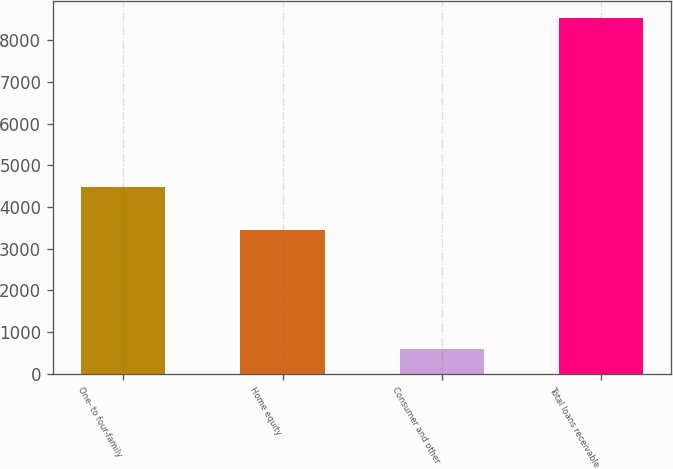Convert chart. <chart><loc_0><loc_0><loc_500><loc_500><bar_chart><fcel>One- to four-family<fcel>Home equity<fcel>Consumer and other<fcel>Total loans receivable<nl><fcel>4475<fcel>3454<fcel>602<fcel>8531<nl></chart> 